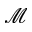Convert formula to latex. <formula><loc_0><loc_0><loc_500><loc_500>\mathcal { M }</formula> 